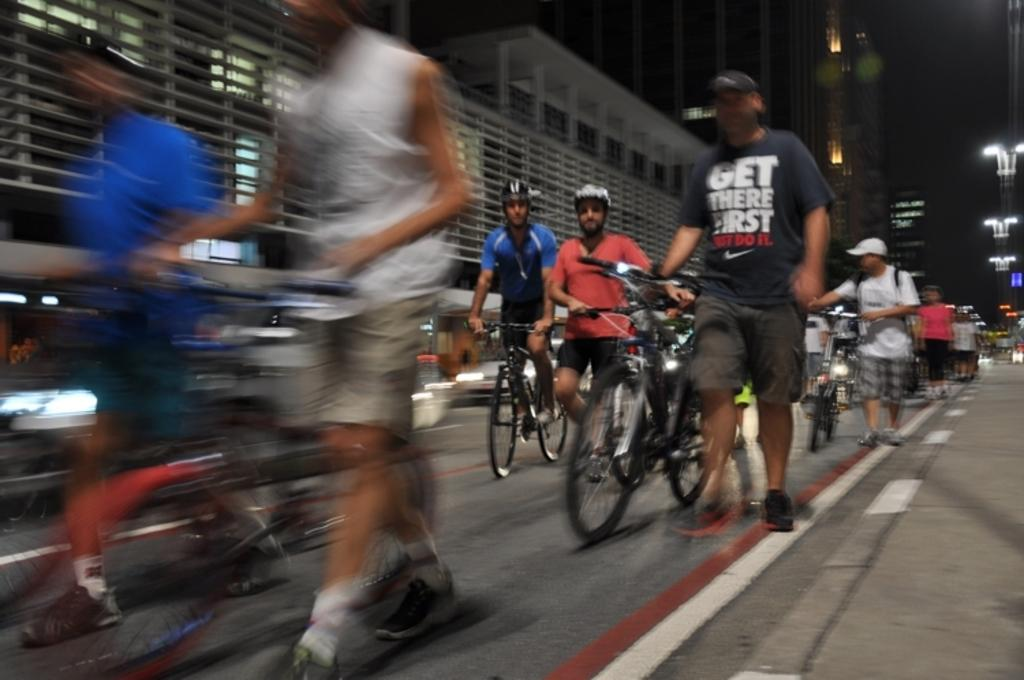What are the people in the image doing? The people in the image are riding bicycles. What type of setting is depicted in the image? The image appears to depict a road. What can be seen on the right side of the image? There are buildings visible on the right side of the image. What type of plastic material can be seen on the rod in the image? There is no rod or plastic material present in the image. 